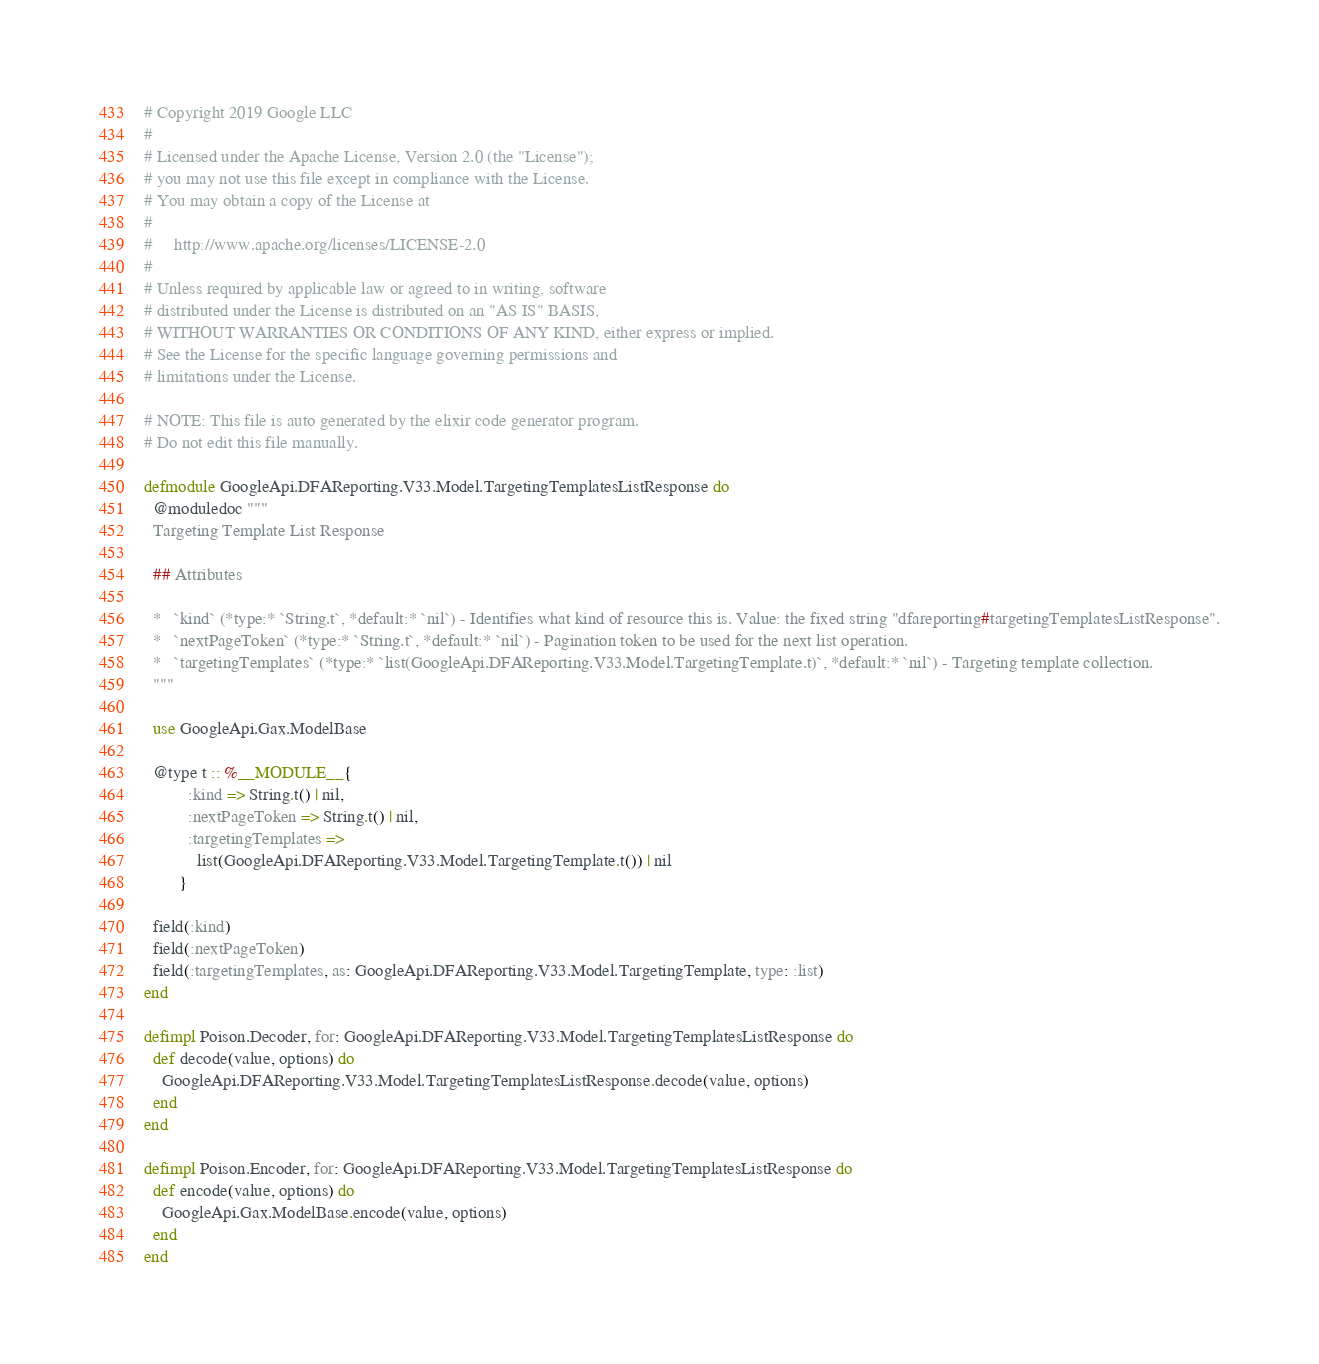Convert code to text. <code><loc_0><loc_0><loc_500><loc_500><_Elixir_># Copyright 2019 Google LLC
#
# Licensed under the Apache License, Version 2.0 (the "License");
# you may not use this file except in compliance with the License.
# You may obtain a copy of the License at
#
#     http://www.apache.org/licenses/LICENSE-2.0
#
# Unless required by applicable law or agreed to in writing, software
# distributed under the License is distributed on an "AS IS" BASIS,
# WITHOUT WARRANTIES OR CONDITIONS OF ANY KIND, either express or implied.
# See the License for the specific language governing permissions and
# limitations under the License.

# NOTE: This file is auto generated by the elixir code generator program.
# Do not edit this file manually.

defmodule GoogleApi.DFAReporting.V33.Model.TargetingTemplatesListResponse do
  @moduledoc """
  Targeting Template List Response

  ## Attributes

  *   `kind` (*type:* `String.t`, *default:* `nil`) - Identifies what kind of resource this is. Value: the fixed string "dfareporting#targetingTemplatesListResponse".
  *   `nextPageToken` (*type:* `String.t`, *default:* `nil`) - Pagination token to be used for the next list operation.
  *   `targetingTemplates` (*type:* `list(GoogleApi.DFAReporting.V33.Model.TargetingTemplate.t)`, *default:* `nil`) - Targeting template collection.
  """

  use GoogleApi.Gax.ModelBase

  @type t :: %__MODULE__{
          :kind => String.t() | nil,
          :nextPageToken => String.t() | nil,
          :targetingTemplates =>
            list(GoogleApi.DFAReporting.V33.Model.TargetingTemplate.t()) | nil
        }

  field(:kind)
  field(:nextPageToken)
  field(:targetingTemplates, as: GoogleApi.DFAReporting.V33.Model.TargetingTemplate, type: :list)
end

defimpl Poison.Decoder, for: GoogleApi.DFAReporting.V33.Model.TargetingTemplatesListResponse do
  def decode(value, options) do
    GoogleApi.DFAReporting.V33.Model.TargetingTemplatesListResponse.decode(value, options)
  end
end

defimpl Poison.Encoder, for: GoogleApi.DFAReporting.V33.Model.TargetingTemplatesListResponse do
  def encode(value, options) do
    GoogleApi.Gax.ModelBase.encode(value, options)
  end
end
</code> 